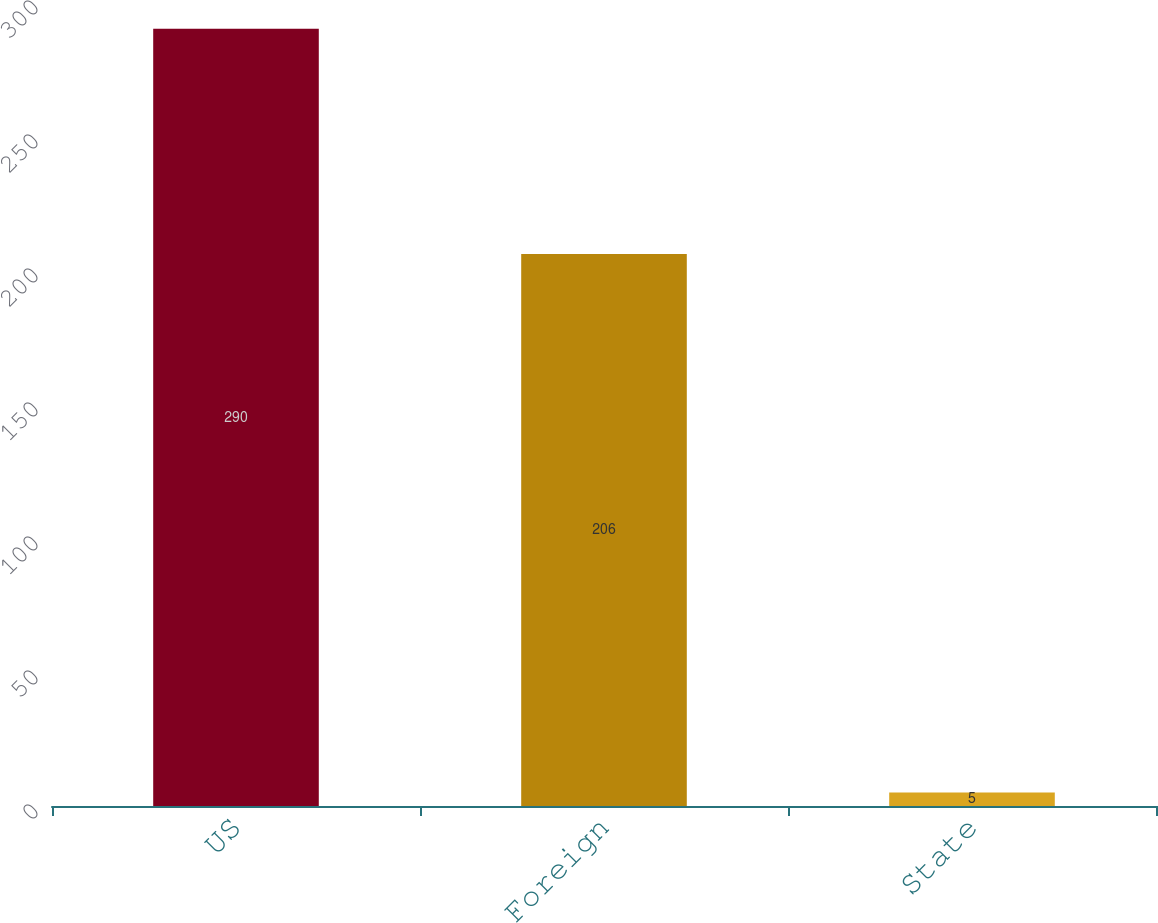Convert chart. <chart><loc_0><loc_0><loc_500><loc_500><bar_chart><fcel>US<fcel>Foreign<fcel>State<nl><fcel>290<fcel>206<fcel>5<nl></chart> 